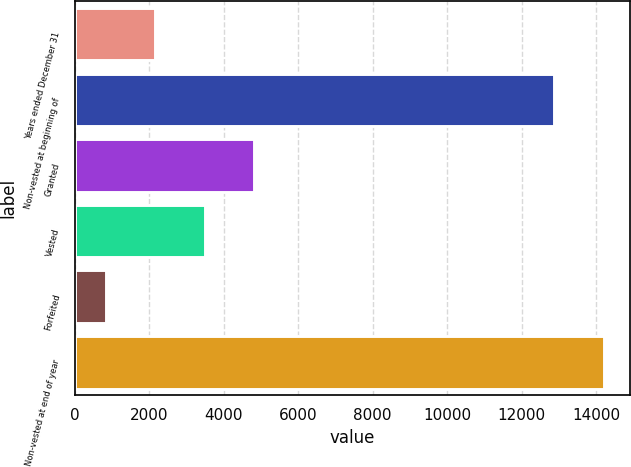Convert chart. <chart><loc_0><loc_0><loc_500><loc_500><bar_chart><fcel>Years ended December 31<fcel>Non-vested at beginning of<fcel>Granted<fcel>Vested<fcel>Forfeited<fcel>Non-vested at end of year<nl><fcel>2163.8<fcel>12870<fcel>4827.4<fcel>3495.6<fcel>832<fcel>14201.8<nl></chart> 